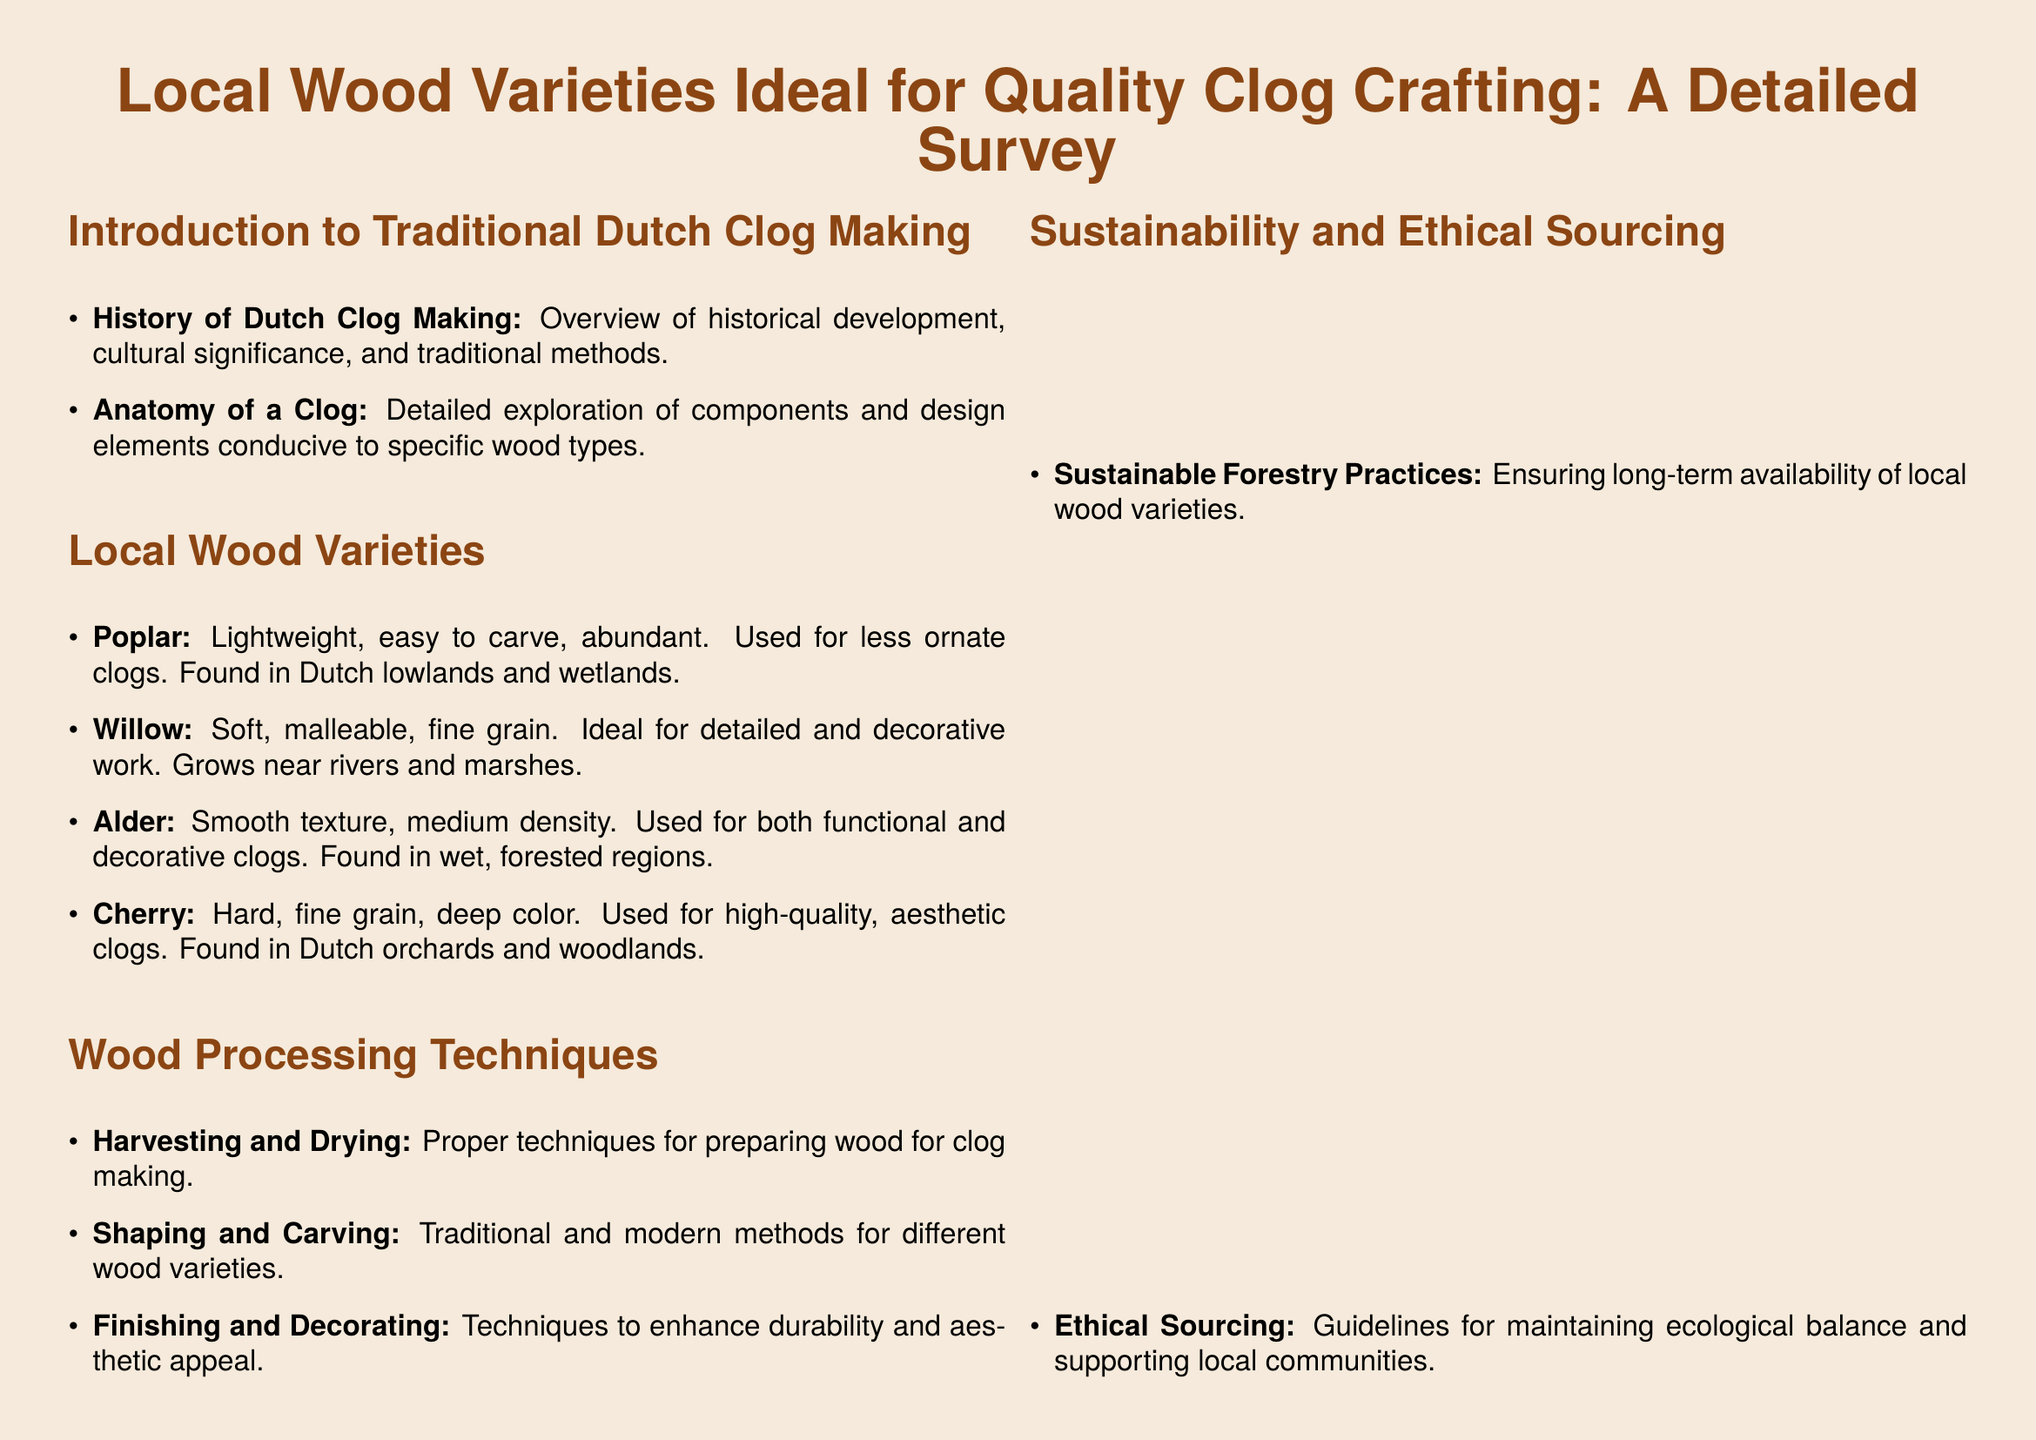what is the title of the document? The title is found at the top of the document, emphasizing the focus on local wood varieties for clog crafting.
Answer: Local Wood Varieties Ideal for Quality Clog Crafting: A Detailed Survey what is the section that discusses the properties of wood? This section lists various wood types along with their characteristics relevant to clog crafting.
Answer: Local Wood Varieties which wood is described as ideal for detailed and decorative work? The specific characteristics mentioned highlight its suitability for intricate designs.
Answer: Willow how many local wood varieties are listed? The document itemizes the wood varieties in the respective section.
Answer: Four what is the hardness of Cherry wood? The table in the document provides a specific measure of Cherry wood's hardness directly.
Answer: High what technique is emphasized for maintaining ecological balance? This refers to practices that encourage sustainability and responsible sourcing of materials.
Answer: Ethical Sourcing how is Alder wood categorized in terms of workability? The provided table indicates how manageable Alder wood is for crafting processes.
Answer: Medium what is the primary focus in the introduction section? This section outlines key themes such as the history and significance of clog making.
Answer: History of Dutch Clog Making 